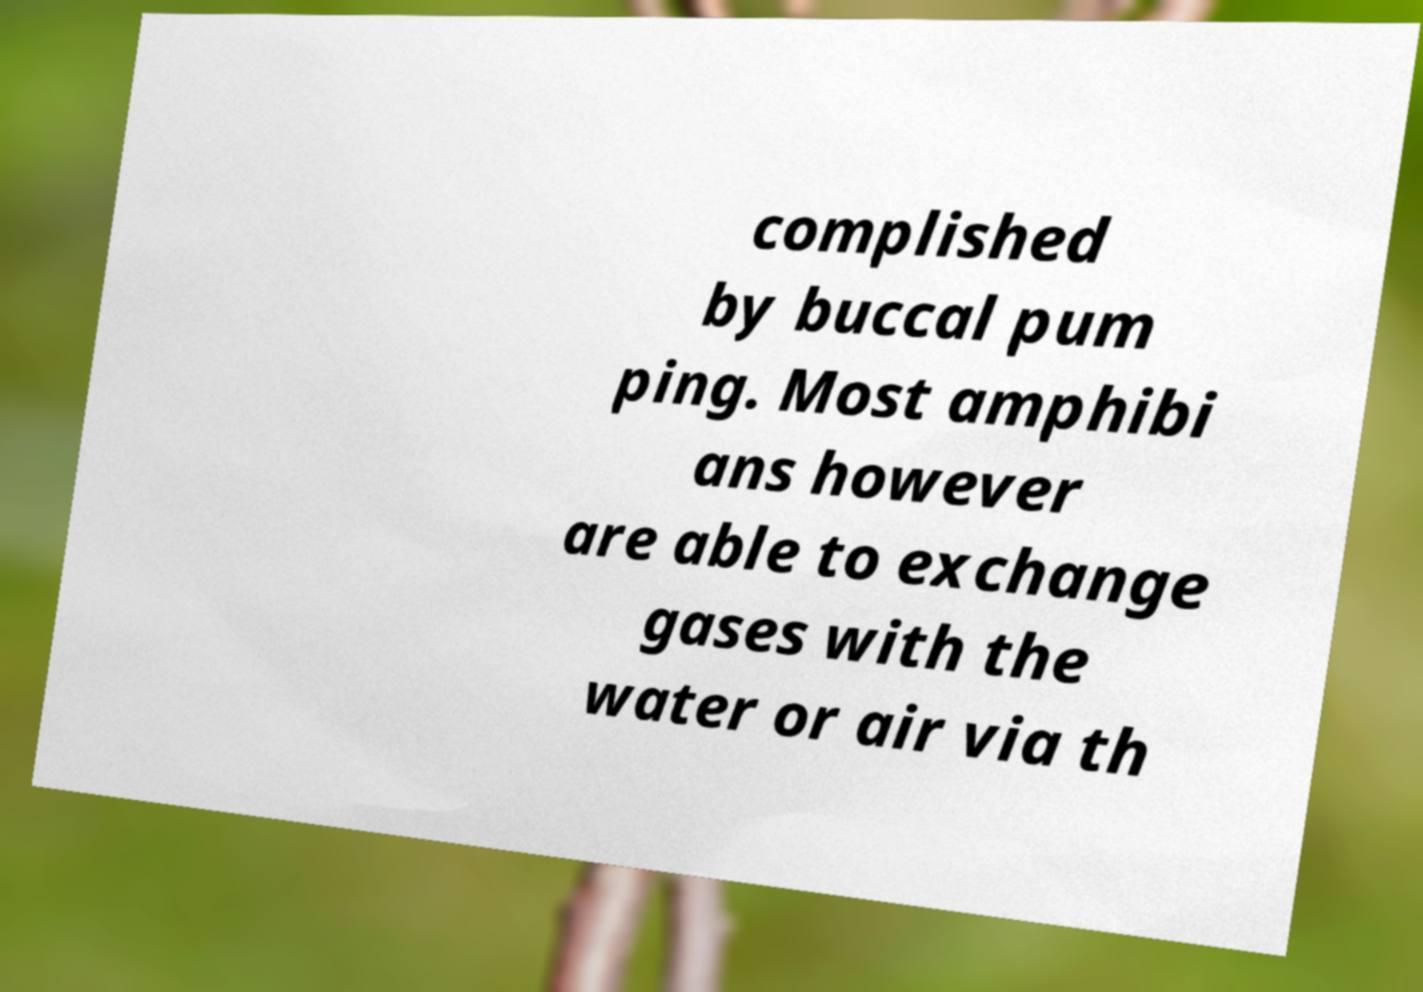Could you extract and type out the text from this image? complished by buccal pum ping. Most amphibi ans however are able to exchange gases with the water or air via th 